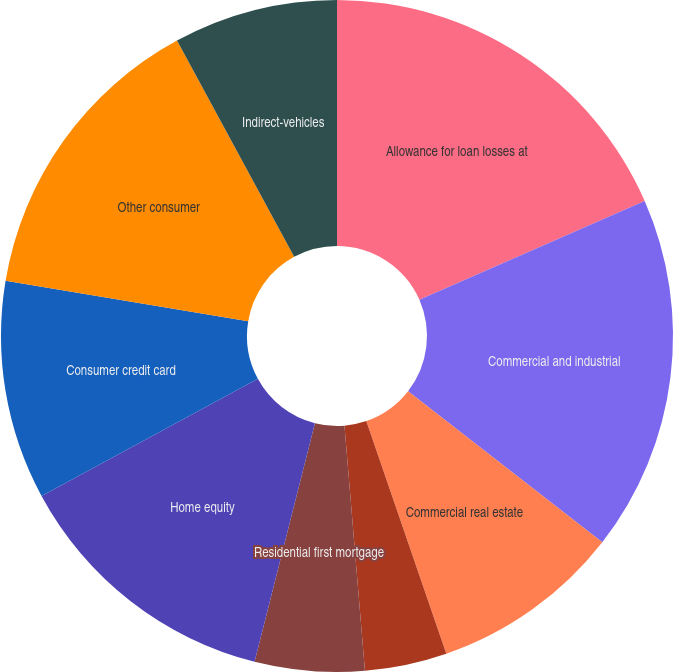Convert chart. <chart><loc_0><loc_0><loc_500><loc_500><pie_chart><fcel>Allowance for loan losses at<fcel>Commercial and industrial<fcel>Commercial real estate<fcel>Commercial investor real<fcel>Residential first mortgage<fcel>Home equity<fcel>Consumer credit card<fcel>Other consumer<fcel>Indirect-vehicles<nl><fcel>18.42%<fcel>17.1%<fcel>9.21%<fcel>3.95%<fcel>5.27%<fcel>13.16%<fcel>10.53%<fcel>14.47%<fcel>7.9%<nl></chart> 